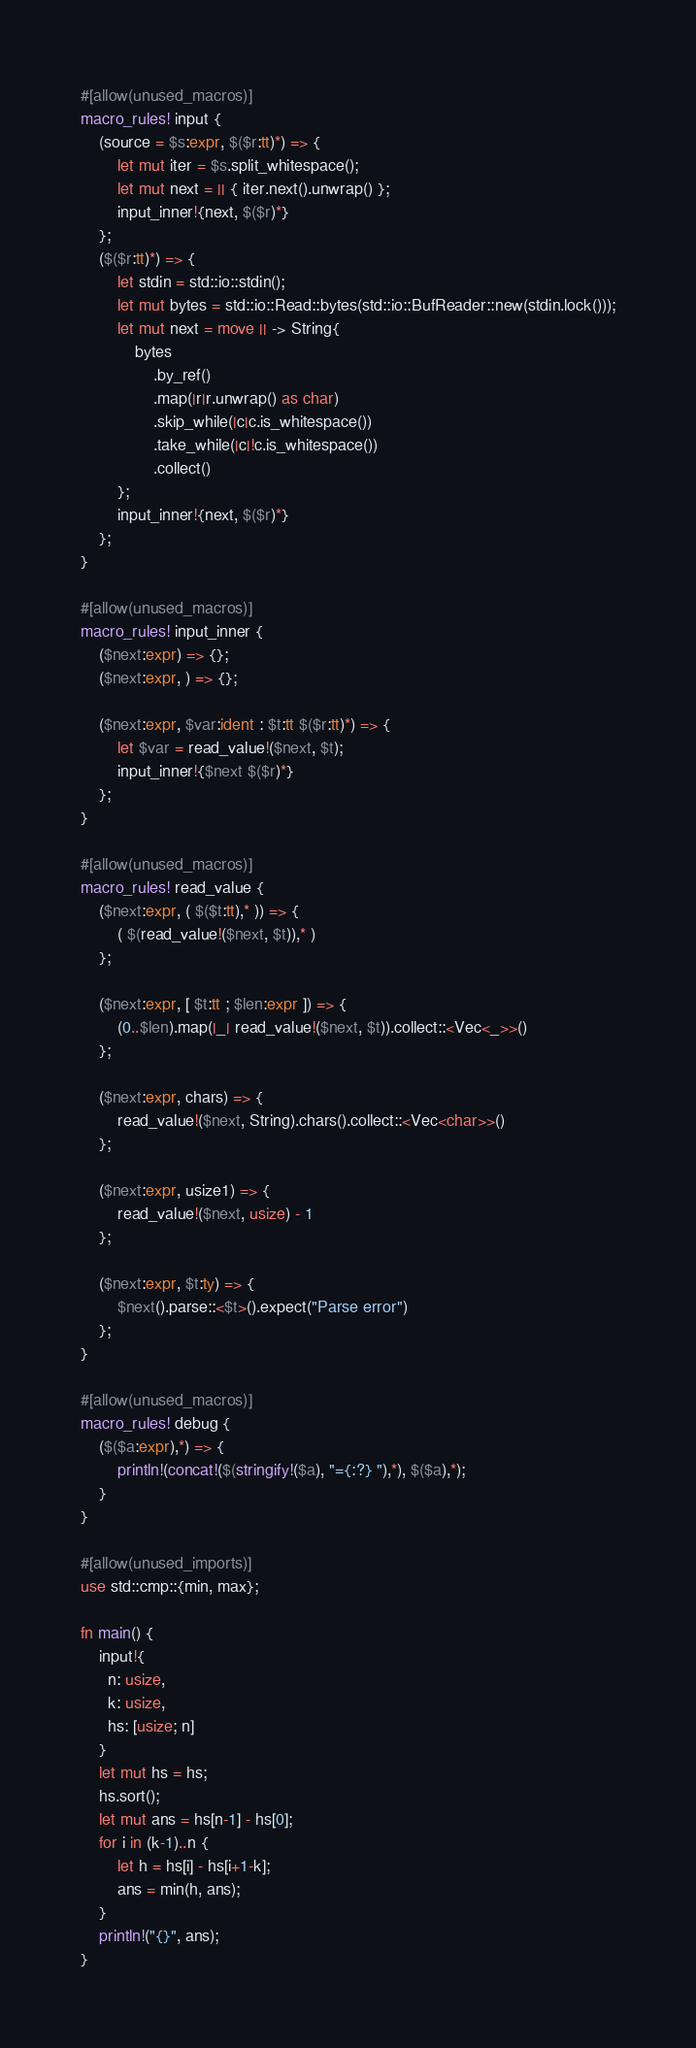Convert code to text. <code><loc_0><loc_0><loc_500><loc_500><_Rust_>#[allow(unused_macros)]
macro_rules! input {
    (source = $s:expr, $($r:tt)*) => {
        let mut iter = $s.split_whitespace();
        let mut next = || { iter.next().unwrap() };
        input_inner!{next, $($r)*}
    };
    ($($r:tt)*) => {
        let stdin = std::io::stdin();
        let mut bytes = std::io::Read::bytes(std::io::BufReader::new(stdin.lock()));
        let mut next = move || -> String{
            bytes
                .by_ref()
                .map(|r|r.unwrap() as char)
                .skip_while(|c|c.is_whitespace())
                .take_while(|c|!c.is_whitespace())
                .collect()
        };
        input_inner!{next, $($r)*}
    };
}

#[allow(unused_macros)]
macro_rules! input_inner {
    ($next:expr) => {};
    ($next:expr, ) => {};

    ($next:expr, $var:ident : $t:tt $($r:tt)*) => {
        let $var = read_value!($next, $t);
        input_inner!{$next $($r)*}
    };
}

#[allow(unused_macros)]
macro_rules! read_value {
    ($next:expr, ( $($t:tt),* )) => {
        ( $(read_value!($next, $t)),* )
    };

    ($next:expr, [ $t:tt ; $len:expr ]) => {
        (0..$len).map(|_| read_value!($next, $t)).collect::<Vec<_>>()
    };

    ($next:expr, chars) => {
        read_value!($next, String).chars().collect::<Vec<char>>()
    };

    ($next:expr, usize1) => {
        read_value!($next, usize) - 1
    };

    ($next:expr, $t:ty) => {
        $next().parse::<$t>().expect("Parse error")
    };
}

#[allow(unused_macros)]
macro_rules! debug {
    ($($a:expr),*) => {
        println!(concat!($(stringify!($a), "={:?} "),*), $($a),*);
    }
}

#[allow(unused_imports)]
use std::cmp::{min, max};

fn main() {
    input!{
      n: usize,
      k: usize,
      hs: [usize; n]
    }
    let mut hs = hs;
    hs.sort();
    let mut ans = hs[n-1] - hs[0];
    for i in (k-1)..n {
        let h = hs[i] - hs[i+1-k];
        ans = min(h, ans);
    }
    println!("{}", ans);
}
</code> 